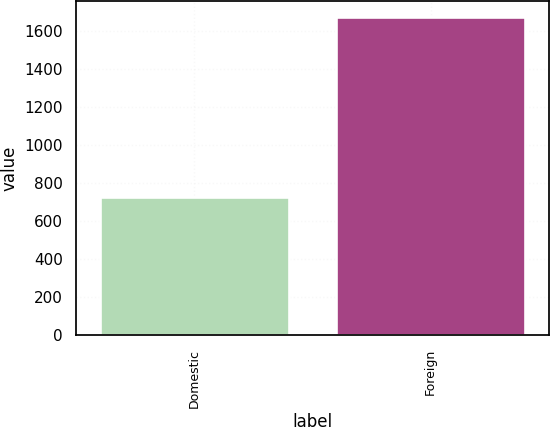Convert chart. <chart><loc_0><loc_0><loc_500><loc_500><bar_chart><fcel>Domestic<fcel>Foreign<nl><fcel>727<fcel>1670<nl></chart> 